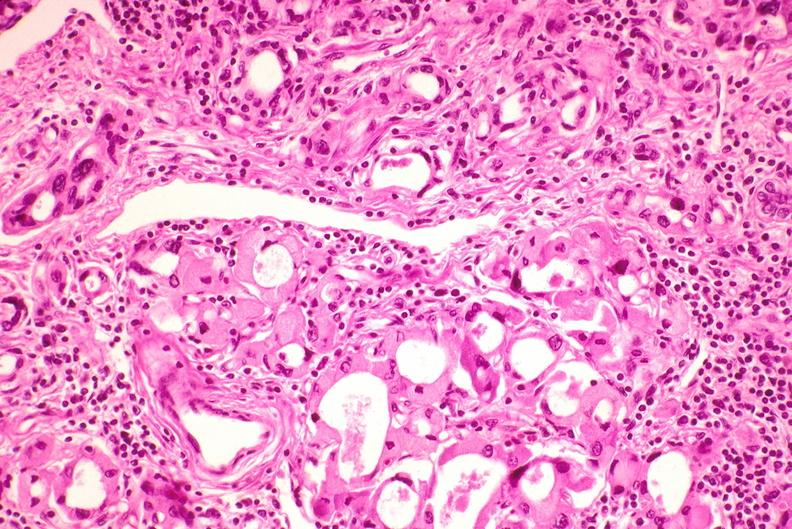what is present?
Answer the question using a single word or phrase. Endocrine 